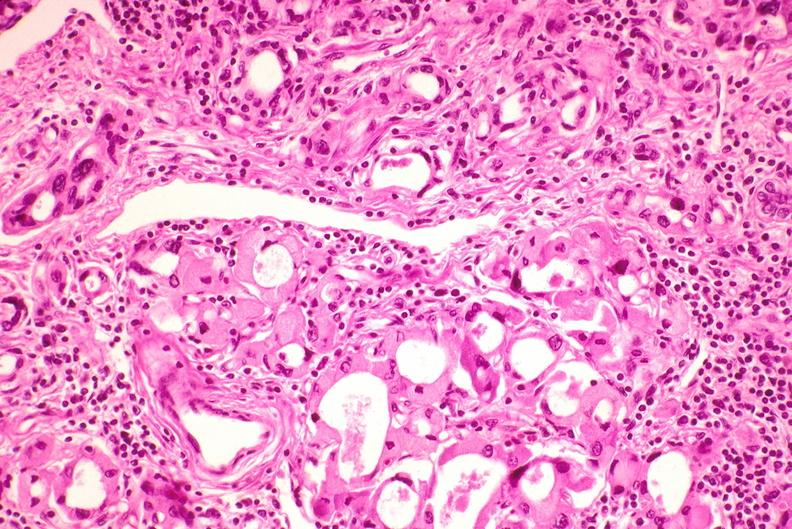what is present?
Answer the question using a single word or phrase. Endocrine 